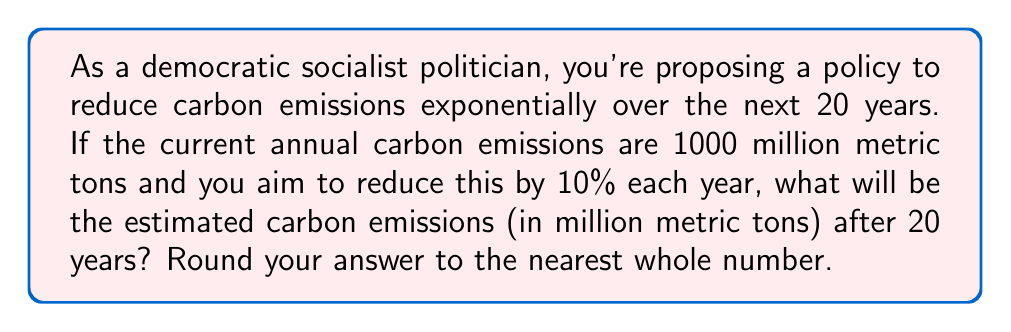Give your solution to this math problem. Let's approach this step-by-step:

1) We start with 1000 million metric tons of carbon emissions.

2) Each year, the emissions are reduced by 10%, which means they become 90% of what they were the previous year.

3) We can represent this as an exponential sequence:
   $$a_n = 1000 \cdot (0.9)^n$$
   where $a_n$ is the amount of emissions after $n$ years.

4) We want to find $a_{20}$, the emissions after 20 years:
   $$a_{20} = 1000 \cdot (0.9)^{20}$$

5) Let's calculate this:
   $$\begin{align}
   a_{20} &= 1000 \cdot (0.9)^{20} \\
   &= 1000 \cdot 0.12157665459056928801 \\
   &= 121.57665459056928801
   \end{align}$$

6) Rounding to the nearest whole number:
   121.57665459056928801 ≈ 122

Therefore, after 20 years, the estimated carbon emissions will be approximately 122 million metric tons.
Answer: 122 million metric tons 